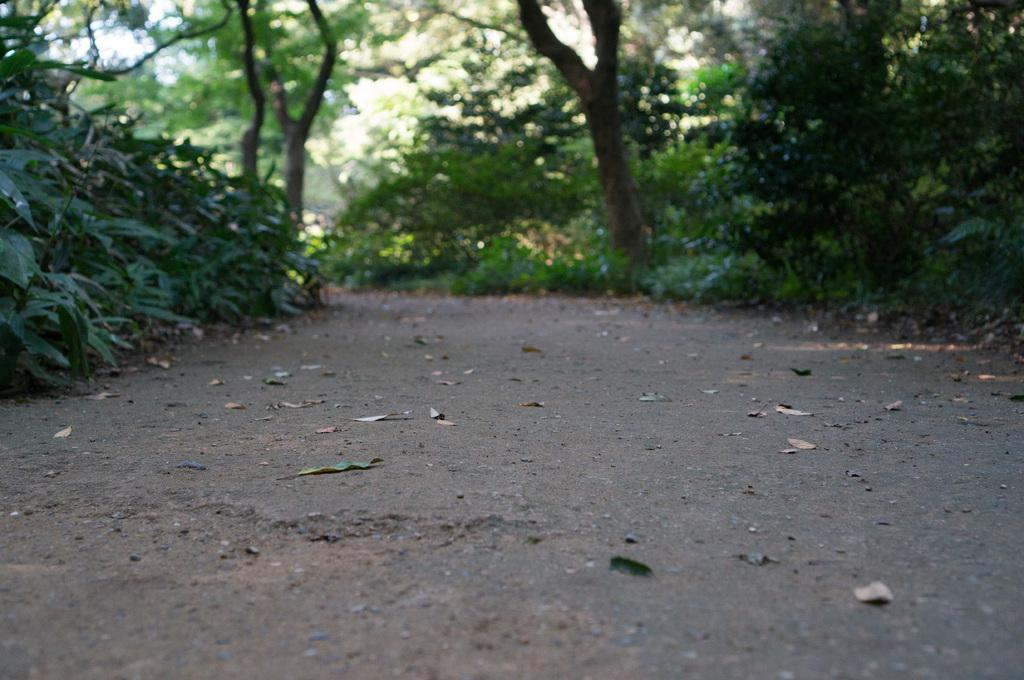How would you summarize this image in a sentence or two? In the foreground we can see dry leaves and path. In the middle of the picture we can see plants and path. In the background there are trees and sky. 